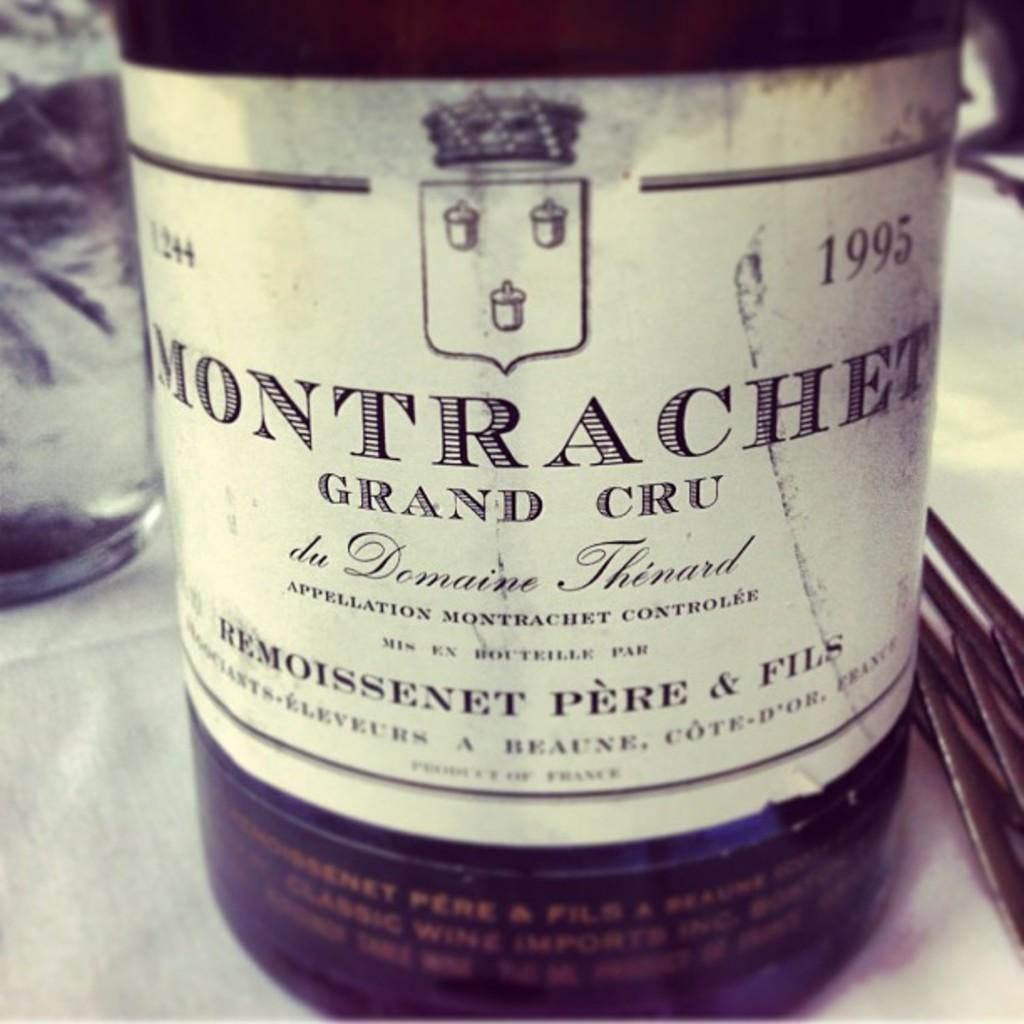<image>
Create a compact narrative representing the image presented. A bottle that has the labeling date of 1995 